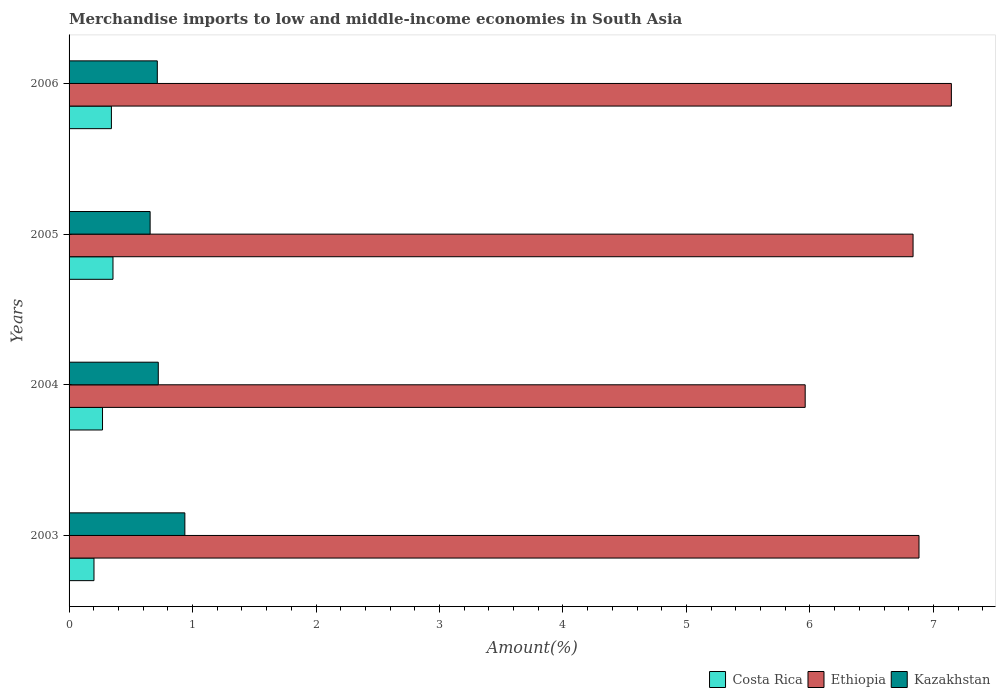Are the number of bars per tick equal to the number of legend labels?
Your answer should be compact. Yes. Are the number of bars on each tick of the Y-axis equal?
Your answer should be very brief. Yes. How many bars are there on the 4th tick from the top?
Provide a succinct answer. 3. What is the label of the 1st group of bars from the top?
Your answer should be compact. 2006. What is the percentage of amount earned from merchandise imports in Kazakhstan in 2004?
Your response must be concise. 0.72. Across all years, what is the maximum percentage of amount earned from merchandise imports in Kazakhstan?
Your response must be concise. 0.94. Across all years, what is the minimum percentage of amount earned from merchandise imports in Ethiopia?
Your answer should be compact. 5.96. In which year was the percentage of amount earned from merchandise imports in Ethiopia maximum?
Provide a short and direct response. 2006. What is the total percentage of amount earned from merchandise imports in Kazakhstan in the graph?
Ensure brevity in your answer.  3.03. What is the difference between the percentage of amount earned from merchandise imports in Ethiopia in 2003 and that in 2004?
Provide a short and direct response. 0.92. What is the difference between the percentage of amount earned from merchandise imports in Kazakhstan in 2006 and the percentage of amount earned from merchandise imports in Costa Rica in 2003?
Provide a short and direct response. 0.51. What is the average percentage of amount earned from merchandise imports in Kazakhstan per year?
Provide a short and direct response. 0.76. In the year 2006, what is the difference between the percentage of amount earned from merchandise imports in Ethiopia and percentage of amount earned from merchandise imports in Kazakhstan?
Ensure brevity in your answer.  6.43. What is the ratio of the percentage of amount earned from merchandise imports in Ethiopia in 2003 to that in 2006?
Ensure brevity in your answer.  0.96. Is the percentage of amount earned from merchandise imports in Ethiopia in 2003 less than that in 2005?
Ensure brevity in your answer.  No. Is the difference between the percentage of amount earned from merchandise imports in Ethiopia in 2003 and 2004 greater than the difference between the percentage of amount earned from merchandise imports in Kazakhstan in 2003 and 2004?
Provide a short and direct response. Yes. What is the difference between the highest and the second highest percentage of amount earned from merchandise imports in Kazakhstan?
Your answer should be very brief. 0.22. What is the difference between the highest and the lowest percentage of amount earned from merchandise imports in Ethiopia?
Provide a succinct answer. 1.18. In how many years, is the percentage of amount earned from merchandise imports in Costa Rica greater than the average percentage of amount earned from merchandise imports in Costa Rica taken over all years?
Your answer should be compact. 2. What does the 2nd bar from the top in 2003 represents?
Your answer should be very brief. Ethiopia. What does the 2nd bar from the bottom in 2004 represents?
Keep it short and to the point. Ethiopia. Are all the bars in the graph horizontal?
Your response must be concise. Yes. How many years are there in the graph?
Ensure brevity in your answer.  4. What is the difference between two consecutive major ticks on the X-axis?
Your response must be concise. 1. Where does the legend appear in the graph?
Ensure brevity in your answer.  Bottom right. How many legend labels are there?
Your answer should be compact. 3. How are the legend labels stacked?
Give a very brief answer. Horizontal. What is the title of the graph?
Provide a succinct answer. Merchandise imports to low and middle-income economies in South Asia. Does "Papua New Guinea" appear as one of the legend labels in the graph?
Offer a terse response. No. What is the label or title of the X-axis?
Make the answer very short. Amount(%). What is the Amount(%) in Costa Rica in 2003?
Your response must be concise. 0.2. What is the Amount(%) in Ethiopia in 2003?
Offer a terse response. 6.88. What is the Amount(%) of Kazakhstan in 2003?
Your answer should be compact. 0.94. What is the Amount(%) of Costa Rica in 2004?
Provide a short and direct response. 0.27. What is the Amount(%) in Ethiopia in 2004?
Your answer should be very brief. 5.96. What is the Amount(%) of Kazakhstan in 2004?
Provide a succinct answer. 0.72. What is the Amount(%) in Costa Rica in 2005?
Your answer should be compact. 0.36. What is the Amount(%) of Ethiopia in 2005?
Your answer should be very brief. 6.84. What is the Amount(%) of Kazakhstan in 2005?
Your answer should be very brief. 0.66. What is the Amount(%) of Costa Rica in 2006?
Your answer should be compact. 0.34. What is the Amount(%) of Ethiopia in 2006?
Make the answer very short. 7.15. What is the Amount(%) in Kazakhstan in 2006?
Offer a terse response. 0.71. Across all years, what is the maximum Amount(%) in Costa Rica?
Keep it short and to the point. 0.36. Across all years, what is the maximum Amount(%) of Ethiopia?
Offer a terse response. 7.15. Across all years, what is the maximum Amount(%) of Kazakhstan?
Your answer should be very brief. 0.94. Across all years, what is the minimum Amount(%) in Costa Rica?
Offer a very short reply. 0.2. Across all years, what is the minimum Amount(%) of Ethiopia?
Provide a succinct answer. 5.96. Across all years, what is the minimum Amount(%) of Kazakhstan?
Your answer should be compact. 0.66. What is the total Amount(%) of Costa Rica in the graph?
Ensure brevity in your answer.  1.17. What is the total Amount(%) of Ethiopia in the graph?
Your answer should be very brief. 26.83. What is the total Amount(%) of Kazakhstan in the graph?
Ensure brevity in your answer.  3.03. What is the difference between the Amount(%) of Costa Rica in 2003 and that in 2004?
Provide a short and direct response. -0.07. What is the difference between the Amount(%) in Ethiopia in 2003 and that in 2004?
Give a very brief answer. 0.92. What is the difference between the Amount(%) of Kazakhstan in 2003 and that in 2004?
Provide a short and direct response. 0.22. What is the difference between the Amount(%) of Costa Rica in 2003 and that in 2005?
Your response must be concise. -0.15. What is the difference between the Amount(%) of Ethiopia in 2003 and that in 2005?
Make the answer very short. 0.05. What is the difference between the Amount(%) in Kazakhstan in 2003 and that in 2005?
Your answer should be very brief. 0.28. What is the difference between the Amount(%) of Costa Rica in 2003 and that in 2006?
Offer a terse response. -0.14. What is the difference between the Amount(%) in Ethiopia in 2003 and that in 2006?
Give a very brief answer. -0.26. What is the difference between the Amount(%) in Kazakhstan in 2003 and that in 2006?
Provide a short and direct response. 0.22. What is the difference between the Amount(%) in Costa Rica in 2004 and that in 2005?
Offer a very short reply. -0.08. What is the difference between the Amount(%) of Ethiopia in 2004 and that in 2005?
Your response must be concise. -0.87. What is the difference between the Amount(%) in Kazakhstan in 2004 and that in 2005?
Make the answer very short. 0.07. What is the difference between the Amount(%) of Costa Rica in 2004 and that in 2006?
Your answer should be very brief. -0.07. What is the difference between the Amount(%) in Ethiopia in 2004 and that in 2006?
Make the answer very short. -1.18. What is the difference between the Amount(%) in Kazakhstan in 2004 and that in 2006?
Your answer should be very brief. 0.01. What is the difference between the Amount(%) in Costa Rica in 2005 and that in 2006?
Provide a succinct answer. 0.01. What is the difference between the Amount(%) in Ethiopia in 2005 and that in 2006?
Make the answer very short. -0.31. What is the difference between the Amount(%) of Kazakhstan in 2005 and that in 2006?
Keep it short and to the point. -0.06. What is the difference between the Amount(%) in Costa Rica in 2003 and the Amount(%) in Ethiopia in 2004?
Your answer should be compact. -5.76. What is the difference between the Amount(%) of Costa Rica in 2003 and the Amount(%) of Kazakhstan in 2004?
Offer a terse response. -0.52. What is the difference between the Amount(%) in Ethiopia in 2003 and the Amount(%) in Kazakhstan in 2004?
Offer a very short reply. 6.16. What is the difference between the Amount(%) of Costa Rica in 2003 and the Amount(%) of Ethiopia in 2005?
Give a very brief answer. -6.63. What is the difference between the Amount(%) in Costa Rica in 2003 and the Amount(%) in Kazakhstan in 2005?
Provide a succinct answer. -0.45. What is the difference between the Amount(%) of Ethiopia in 2003 and the Amount(%) of Kazakhstan in 2005?
Make the answer very short. 6.23. What is the difference between the Amount(%) in Costa Rica in 2003 and the Amount(%) in Ethiopia in 2006?
Offer a very short reply. -6.94. What is the difference between the Amount(%) in Costa Rica in 2003 and the Amount(%) in Kazakhstan in 2006?
Ensure brevity in your answer.  -0.51. What is the difference between the Amount(%) of Ethiopia in 2003 and the Amount(%) of Kazakhstan in 2006?
Provide a succinct answer. 6.17. What is the difference between the Amount(%) in Costa Rica in 2004 and the Amount(%) in Ethiopia in 2005?
Make the answer very short. -6.56. What is the difference between the Amount(%) in Costa Rica in 2004 and the Amount(%) in Kazakhstan in 2005?
Provide a short and direct response. -0.39. What is the difference between the Amount(%) in Ethiopia in 2004 and the Amount(%) in Kazakhstan in 2005?
Provide a succinct answer. 5.31. What is the difference between the Amount(%) in Costa Rica in 2004 and the Amount(%) in Ethiopia in 2006?
Offer a very short reply. -6.87. What is the difference between the Amount(%) of Costa Rica in 2004 and the Amount(%) of Kazakhstan in 2006?
Ensure brevity in your answer.  -0.44. What is the difference between the Amount(%) of Ethiopia in 2004 and the Amount(%) of Kazakhstan in 2006?
Ensure brevity in your answer.  5.25. What is the difference between the Amount(%) of Costa Rica in 2005 and the Amount(%) of Ethiopia in 2006?
Your answer should be very brief. -6.79. What is the difference between the Amount(%) in Costa Rica in 2005 and the Amount(%) in Kazakhstan in 2006?
Provide a succinct answer. -0.36. What is the difference between the Amount(%) in Ethiopia in 2005 and the Amount(%) in Kazakhstan in 2006?
Your answer should be very brief. 6.12. What is the average Amount(%) in Costa Rica per year?
Offer a very short reply. 0.29. What is the average Amount(%) in Ethiopia per year?
Keep it short and to the point. 6.71. What is the average Amount(%) of Kazakhstan per year?
Make the answer very short. 0.76. In the year 2003, what is the difference between the Amount(%) in Costa Rica and Amount(%) in Ethiopia?
Give a very brief answer. -6.68. In the year 2003, what is the difference between the Amount(%) of Costa Rica and Amount(%) of Kazakhstan?
Your response must be concise. -0.74. In the year 2003, what is the difference between the Amount(%) in Ethiopia and Amount(%) in Kazakhstan?
Provide a short and direct response. 5.95. In the year 2004, what is the difference between the Amount(%) in Costa Rica and Amount(%) in Ethiopia?
Give a very brief answer. -5.69. In the year 2004, what is the difference between the Amount(%) in Costa Rica and Amount(%) in Kazakhstan?
Your response must be concise. -0.45. In the year 2004, what is the difference between the Amount(%) of Ethiopia and Amount(%) of Kazakhstan?
Provide a succinct answer. 5.24. In the year 2005, what is the difference between the Amount(%) in Costa Rica and Amount(%) in Ethiopia?
Provide a succinct answer. -6.48. In the year 2005, what is the difference between the Amount(%) of Costa Rica and Amount(%) of Kazakhstan?
Ensure brevity in your answer.  -0.3. In the year 2005, what is the difference between the Amount(%) of Ethiopia and Amount(%) of Kazakhstan?
Your answer should be very brief. 6.18. In the year 2006, what is the difference between the Amount(%) in Costa Rica and Amount(%) in Ethiopia?
Offer a terse response. -6.8. In the year 2006, what is the difference between the Amount(%) in Costa Rica and Amount(%) in Kazakhstan?
Ensure brevity in your answer.  -0.37. In the year 2006, what is the difference between the Amount(%) in Ethiopia and Amount(%) in Kazakhstan?
Keep it short and to the point. 6.43. What is the ratio of the Amount(%) of Costa Rica in 2003 to that in 2004?
Keep it short and to the point. 0.74. What is the ratio of the Amount(%) of Ethiopia in 2003 to that in 2004?
Offer a very short reply. 1.15. What is the ratio of the Amount(%) in Kazakhstan in 2003 to that in 2004?
Your answer should be compact. 1.3. What is the ratio of the Amount(%) in Costa Rica in 2003 to that in 2005?
Provide a short and direct response. 0.57. What is the ratio of the Amount(%) in Kazakhstan in 2003 to that in 2005?
Your answer should be very brief. 1.43. What is the ratio of the Amount(%) in Costa Rica in 2003 to that in 2006?
Give a very brief answer. 0.59. What is the ratio of the Amount(%) in Ethiopia in 2003 to that in 2006?
Give a very brief answer. 0.96. What is the ratio of the Amount(%) of Kazakhstan in 2003 to that in 2006?
Keep it short and to the point. 1.31. What is the ratio of the Amount(%) of Costa Rica in 2004 to that in 2005?
Your response must be concise. 0.76. What is the ratio of the Amount(%) in Ethiopia in 2004 to that in 2005?
Offer a terse response. 0.87. What is the ratio of the Amount(%) of Kazakhstan in 2004 to that in 2005?
Make the answer very short. 1.1. What is the ratio of the Amount(%) in Costa Rica in 2004 to that in 2006?
Your response must be concise. 0.79. What is the ratio of the Amount(%) of Ethiopia in 2004 to that in 2006?
Your answer should be very brief. 0.83. What is the ratio of the Amount(%) in Kazakhstan in 2004 to that in 2006?
Make the answer very short. 1.01. What is the ratio of the Amount(%) in Costa Rica in 2005 to that in 2006?
Keep it short and to the point. 1.04. What is the ratio of the Amount(%) in Ethiopia in 2005 to that in 2006?
Offer a very short reply. 0.96. What is the ratio of the Amount(%) of Kazakhstan in 2005 to that in 2006?
Give a very brief answer. 0.92. What is the difference between the highest and the second highest Amount(%) in Costa Rica?
Provide a short and direct response. 0.01. What is the difference between the highest and the second highest Amount(%) of Ethiopia?
Provide a succinct answer. 0.26. What is the difference between the highest and the second highest Amount(%) in Kazakhstan?
Your answer should be compact. 0.22. What is the difference between the highest and the lowest Amount(%) of Costa Rica?
Offer a very short reply. 0.15. What is the difference between the highest and the lowest Amount(%) of Ethiopia?
Make the answer very short. 1.18. What is the difference between the highest and the lowest Amount(%) of Kazakhstan?
Ensure brevity in your answer.  0.28. 